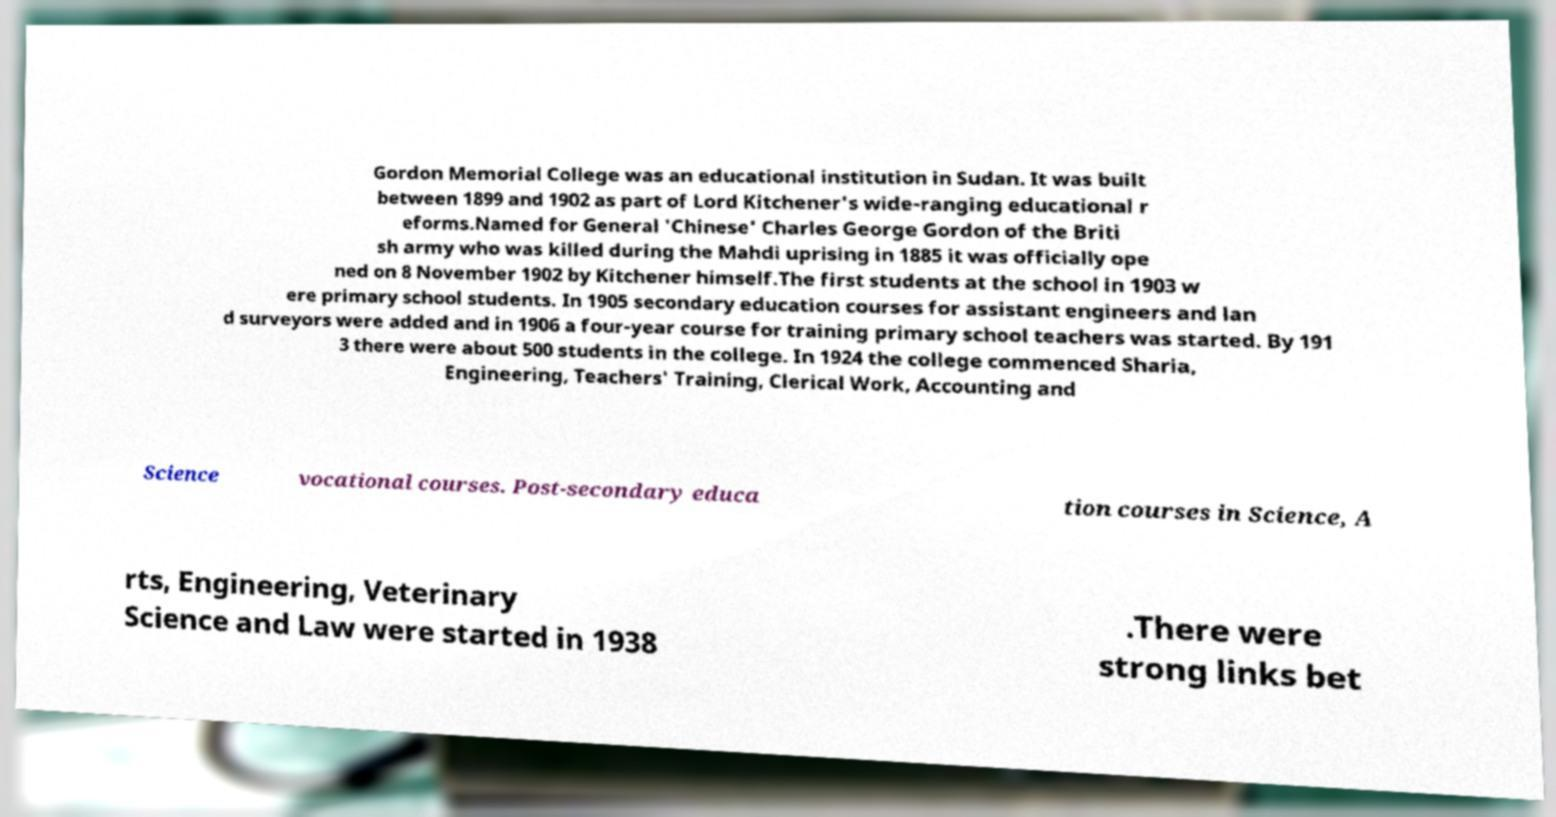Please read and relay the text visible in this image. What does it say? Gordon Memorial College was an educational institution in Sudan. It was built between 1899 and 1902 as part of Lord Kitchener's wide-ranging educational r eforms.Named for General 'Chinese' Charles George Gordon of the Briti sh army who was killed during the Mahdi uprising in 1885 it was officially ope ned on 8 November 1902 by Kitchener himself.The first students at the school in 1903 w ere primary school students. In 1905 secondary education courses for assistant engineers and lan d surveyors were added and in 1906 a four-year course for training primary school teachers was started. By 191 3 there were about 500 students in the college. In 1924 the college commenced Sharia, Engineering, Teachers' Training, Clerical Work, Accounting and Science vocational courses. Post-secondary educa tion courses in Science, A rts, Engineering, Veterinary Science and Law were started in 1938 .There were strong links bet 